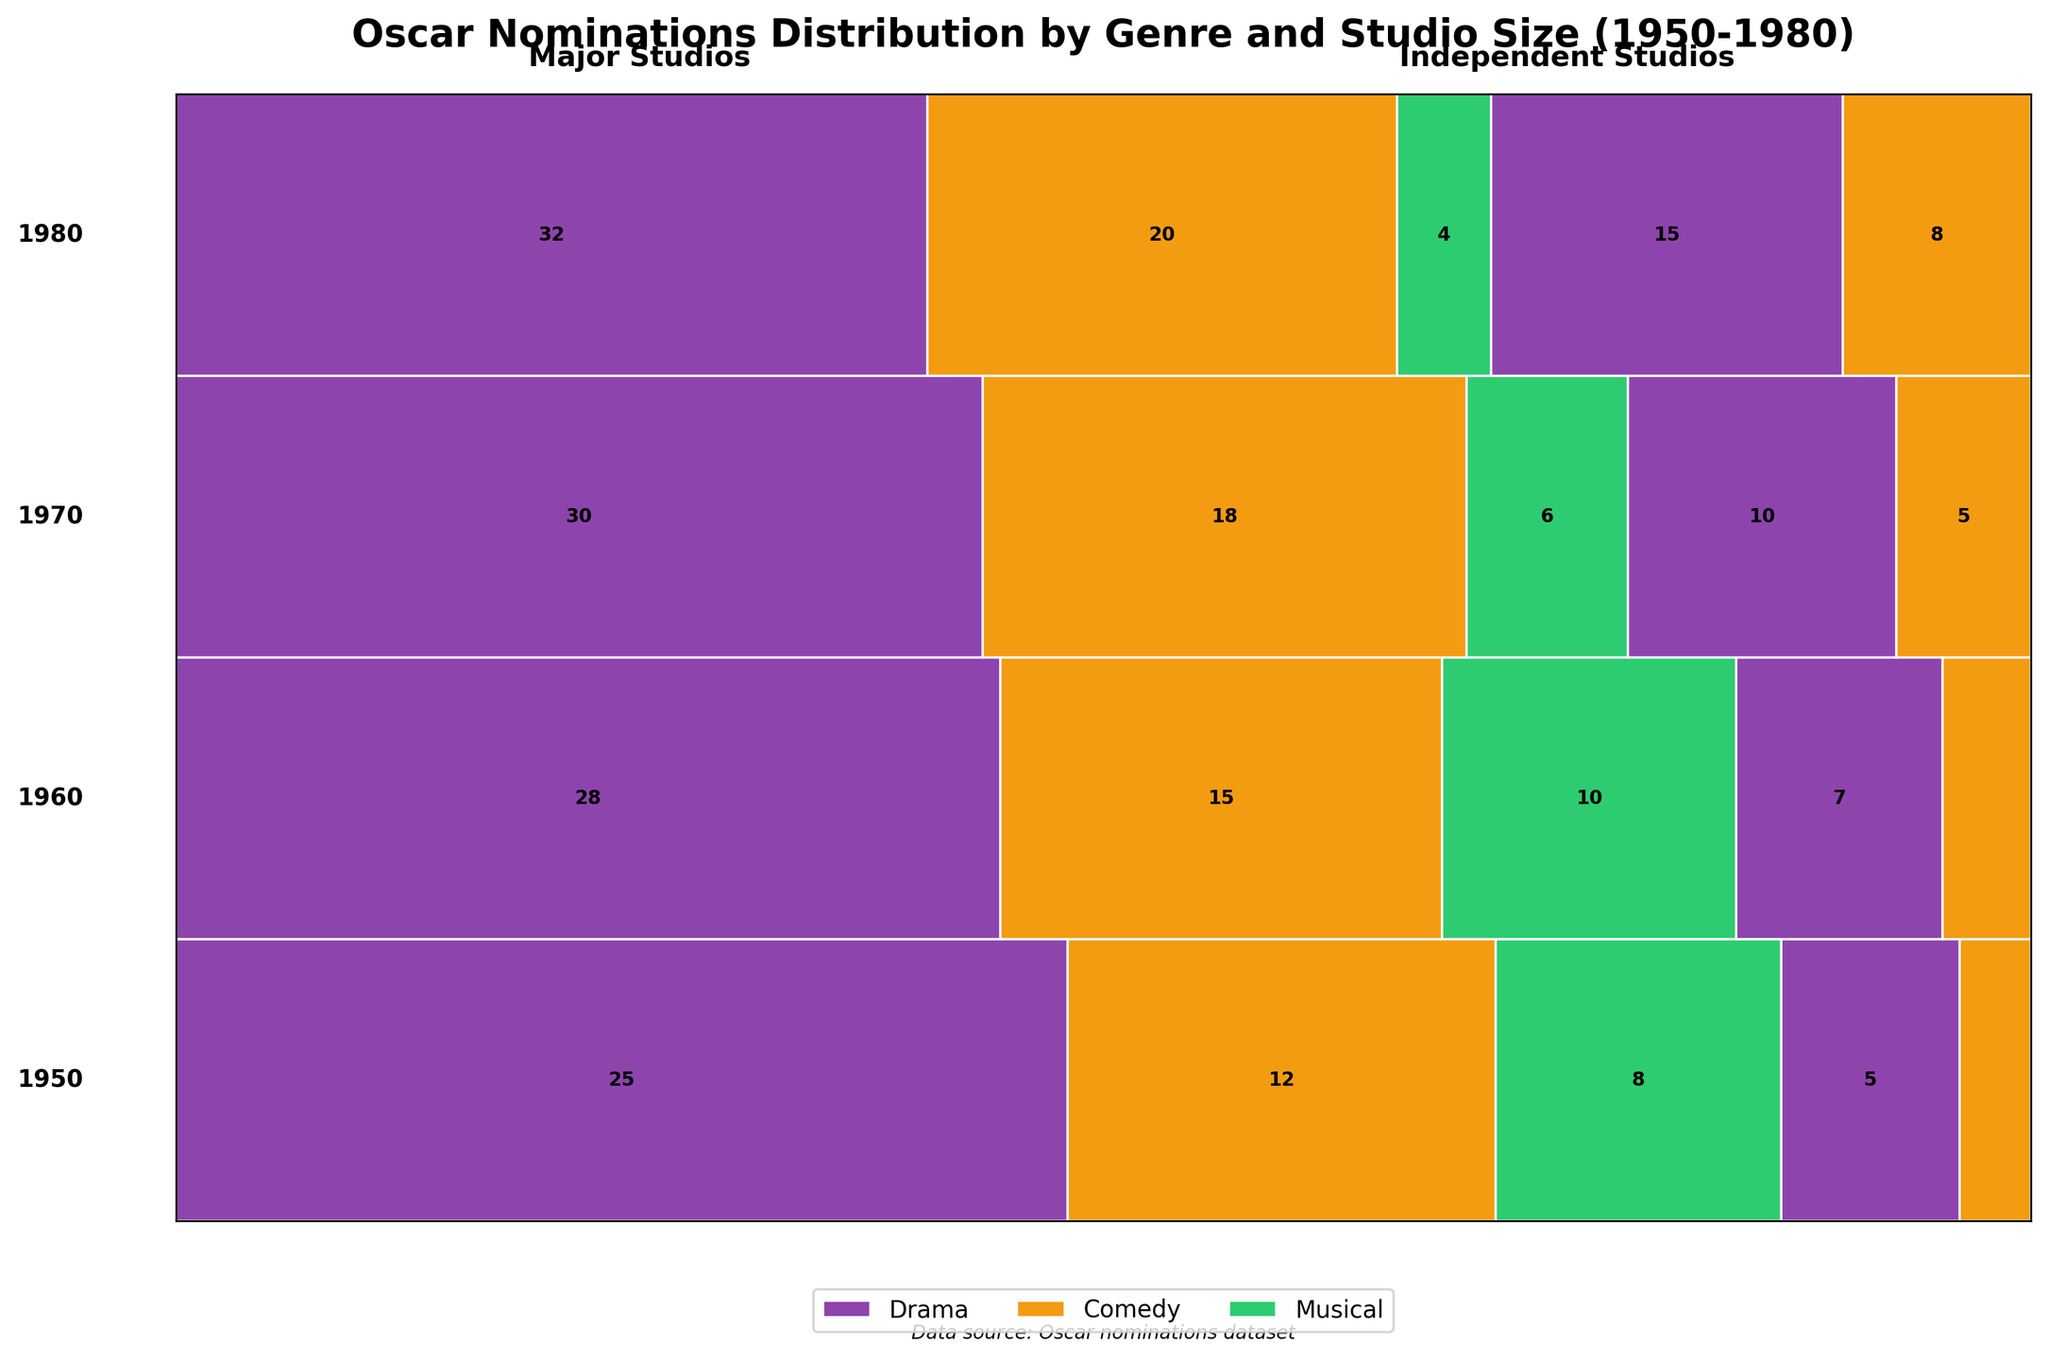What is the title of the diagram? The title is displayed at the top of the diagram.
Answer: Oscar Nominations Distribution by Genre and Studio Size (1950-1980) Which genre has the most nominations in 1960 for major studios? Look for the year 1960, find the major studios section, and identify the genre with the widest rectangle.
Answer: Drama How many Oscar nominations did independent studios get in 1980 for the Comedy genre? Locate the year 1980 and find the section for Comedy under independent studios, then read the number inside the rectangle.
Answer: 8 In which year did major studios receive the fewest nominations for Musicals? For each year (1950, 1960, 1970, 1980), compare the width of the rectangles representing Musicals in the major studios section.
Answer: 1980 Compare the total nominations of the Drama genre between major and independent studios in 1970. Which one has more, and by how many? Calculate the total nominations for the Drama genre in 1970 by adding the numbers for major and independent studios, then find the difference. Major: 30, Independent: 10, Difference = 30 - 10.
Answer: Major studios, by 20 What trend can be observed for major studios' nominations in the Drama genre from 1950 to 1980? Observe the rectangles for Drama under major studios for the sequential years (1950, 1960, 1970, 1980) and note any trends. Nominations increase each decade (25, 28, 30, 32).
Answer: Increasing trend How do the nominations for Comedy in major studios change from 1950 to 1980? Examine the rectangles for Comedy under major studios for the years 1950, 1960, 1970, 1980, and note changes. The nominations are 12, 15, 18, 20.
Answer: Increase over time Are nominations for Drama independent studios consistent, increasing, or decreasing from 1950 to 1980? Observe the rectangles for Drama under independent studios for the years 1950, 1960, 1970, 1980: 5, 7, 10, 15.
Answer: Increasing What's the ratio of Musical to Comedy nominations for major studios in 1950? For 1950, look at the number of nominations for Musical (8) and Comedy (12) within major studios. Compute the ratio 8/12.
Answer: 2:3 Which year had the most balanced distribution of nominations between Drama and Comedy for independent studios? For each year (1950, 1960, 1970, 1980), compare the Drama and Comedy nominations in independent studios and find the smallest difference.
Answer: 1960 